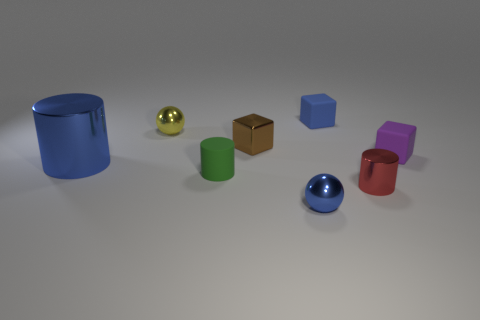What number of small objects are made of the same material as the tiny brown cube?
Provide a short and direct response. 3. Is the number of small rubber cubes to the left of the tiny yellow metal object less than the number of big metal objects right of the large blue cylinder?
Your response must be concise. No. What is the material of the blue block behind the small cylinder behind the red shiny object that is in front of the metal block?
Your response must be concise. Rubber. What is the size of the rubber thing that is both to the left of the small red thing and behind the large blue metal object?
Ensure brevity in your answer.  Small. What number of cylinders are either purple matte things or brown things?
Your answer should be compact. 0. What is the color of the matte cylinder that is the same size as the blue block?
Your response must be concise. Green. Is there any other thing that is the same shape as the small blue rubber object?
Provide a succinct answer. Yes. There is another tiny object that is the same shape as the small yellow shiny thing; what is its color?
Give a very brief answer. Blue. How many objects are either large blue cylinders or small blue objects behind the blue shiny ball?
Ensure brevity in your answer.  2. Is the number of tiny brown blocks behind the small brown metallic object less than the number of small gray cylinders?
Give a very brief answer. No. 